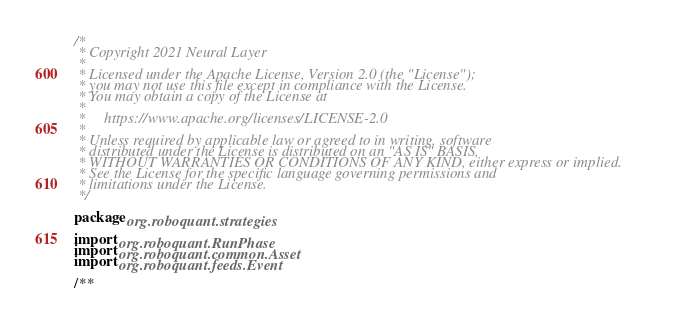Convert code to text. <code><loc_0><loc_0><loc_500><loc_500><_Kotlin_>/*
 * Copyright 2021 Neural Layer
 *
 * Licensed under the Apache License, Version 2.0 (the "License");
 * you may not use this file except in compliance with the License.
 * You may obtain a copy of the License at
 *
 *     https://www.apache.org/licenses/LICENSE-2.0
 *
 * Unless required by applicable law or agreed to in writing, software
 * distributed under the License is distributed on an "AS IS" BASIS,
 * WITHOUT WARRANTIES OR CONDITIONS OF ANY KIND, either express or implied.
 * See the License for the specific language governing permissions and
 * limitations under the License.
 */

package org.roboquant.strategies

import org.roboquant.RunPhase
import org.roboquant.common.Asset
import org.roboquant.feeds.Event

/**</code> 